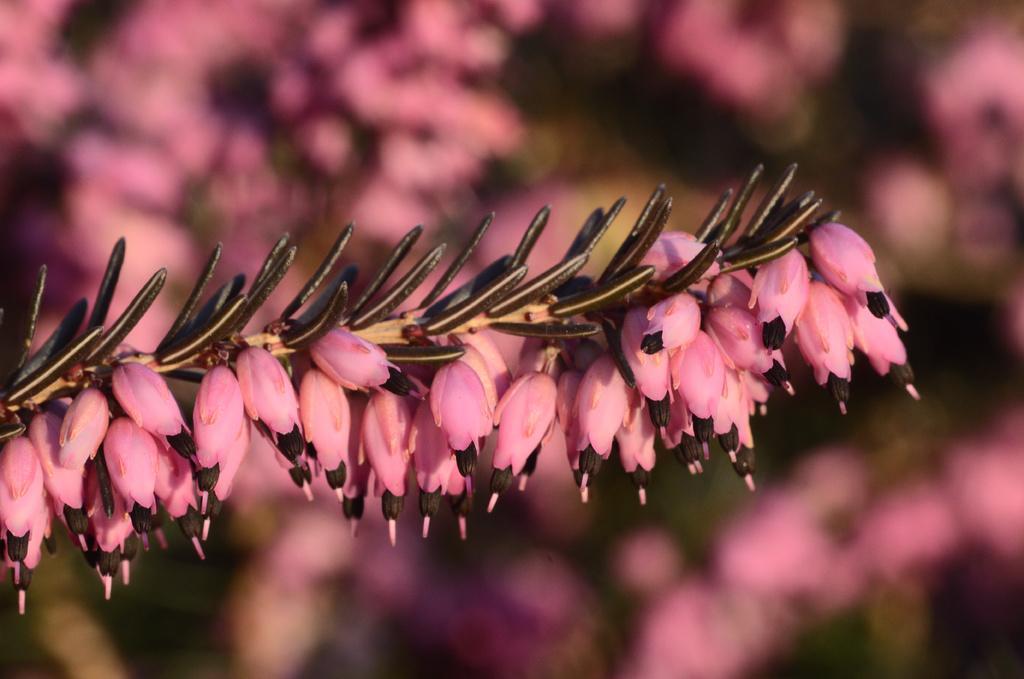In one or two sentences, can you explain what this image depicts? In this image I can see there are flowers in pink color and there are buds in brown color. 